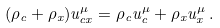<formula> <loc_0><loc_0><loc_500><loc_500>( \rho _ { c } + \rho _ { x } ) u ^ { \mu } _ { c x } = \rho _ { c } u ^ { \mu } _ { c } + \rho _ { x } u ^ { \mu } _ { x } \, .</formula> 